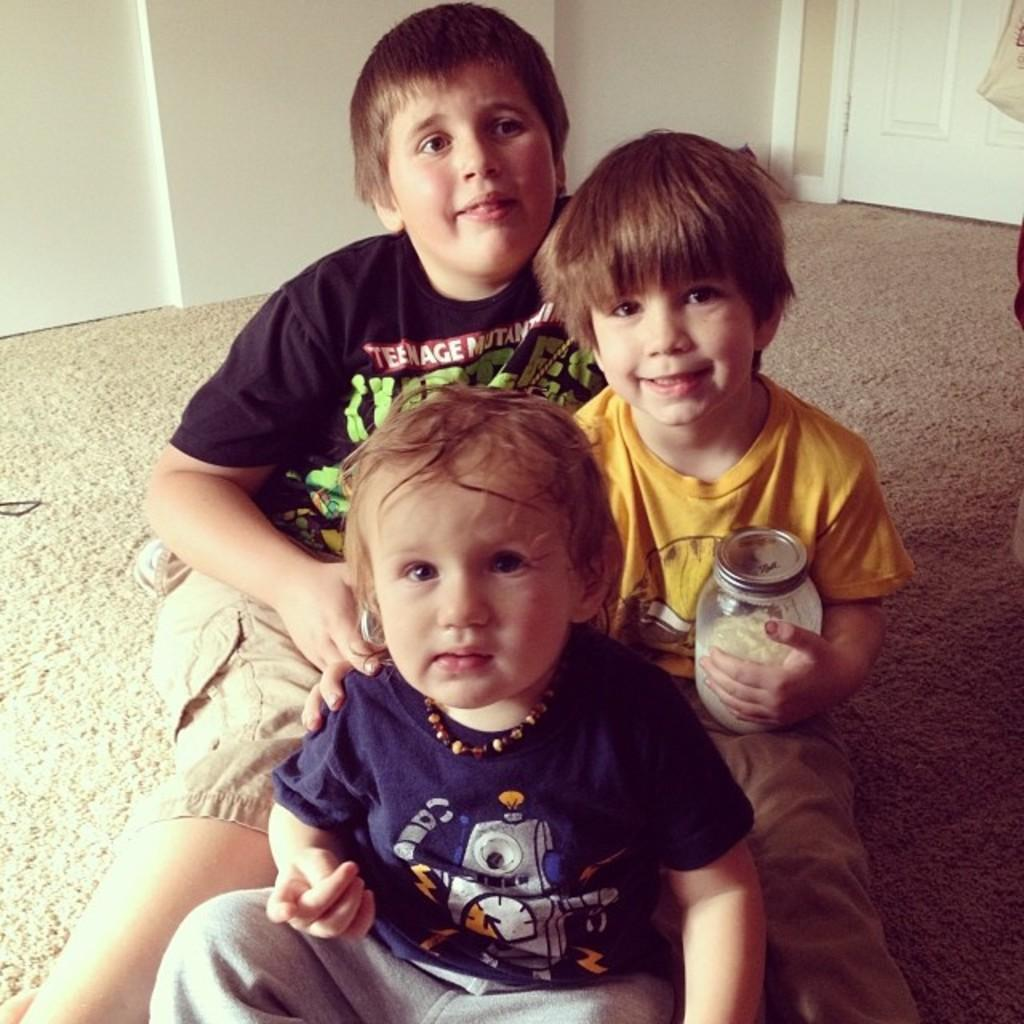How many people are sitting on the floor in the image? There are three people sitting on the floor in the image. What is the boy holding in the image? The boy is holding a glass bottle in the image. What color is the wall in the background? The wall in the background is white. Can you identify any architectural features in the image? Yes, there is a door in the image. Where is the tray placed in the image? There is no tray present in the image. Can you see a kitty playing with a stamp in the image? There is no kitty or stamp present in the image. 